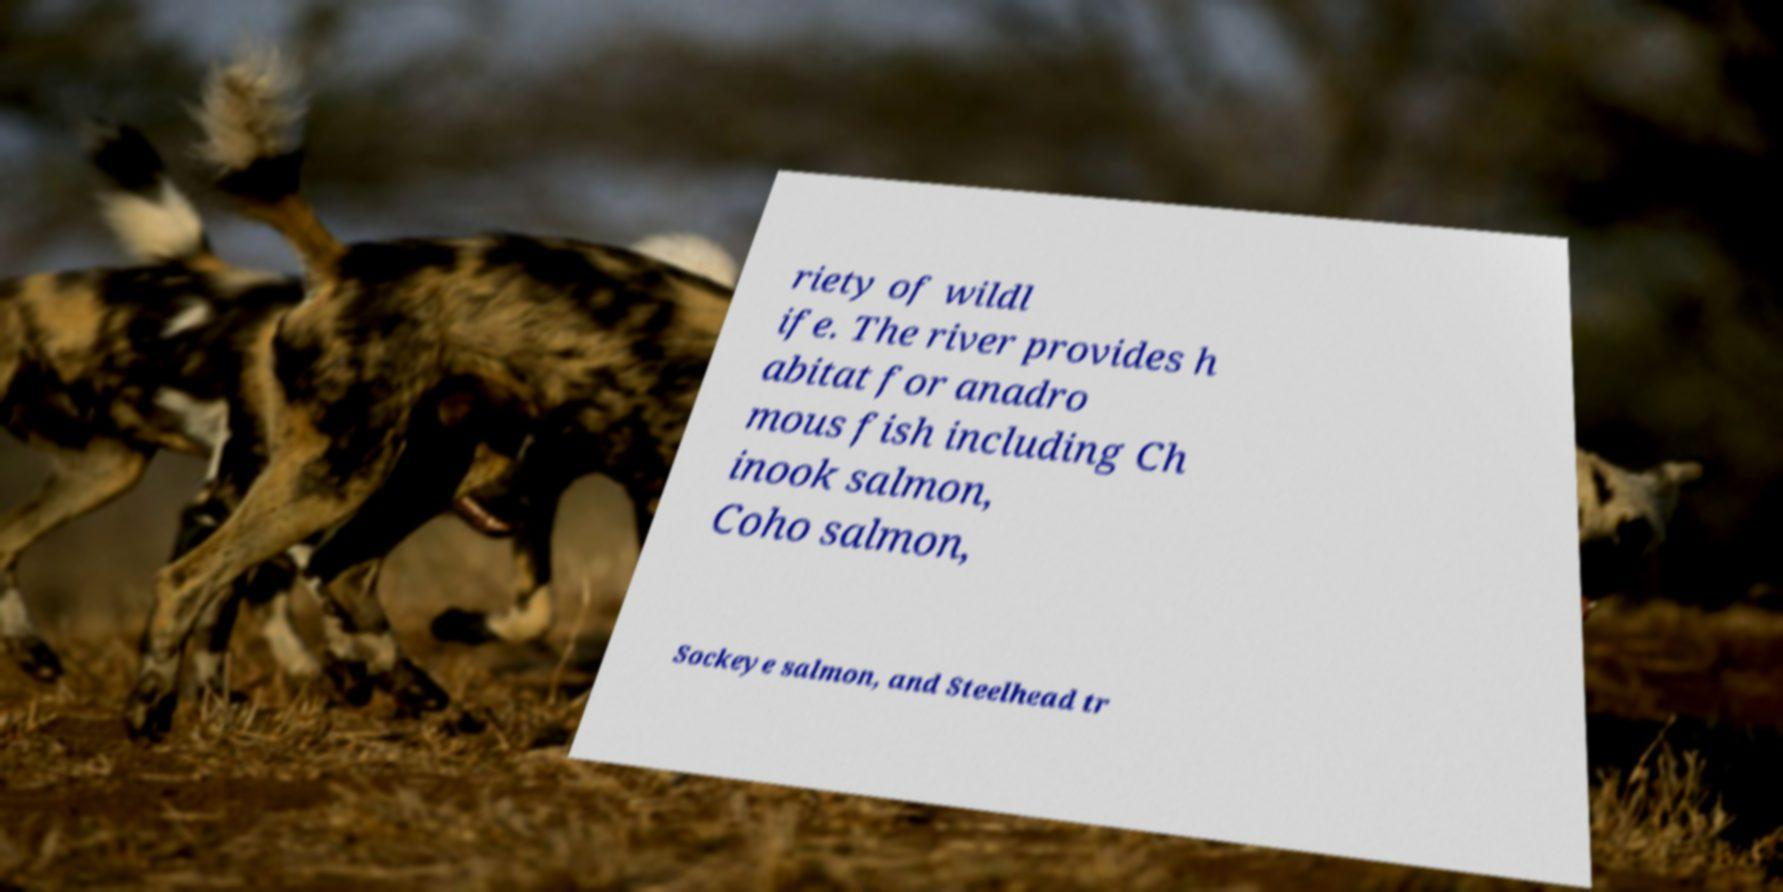I need the written content from this picture converted into text. Can you do that? riety of wildl ife. The river provides h abitat for anadro mous fish including Ch inook salmon, Coho salmon, Sockeye salmon, and Steelhead tr 